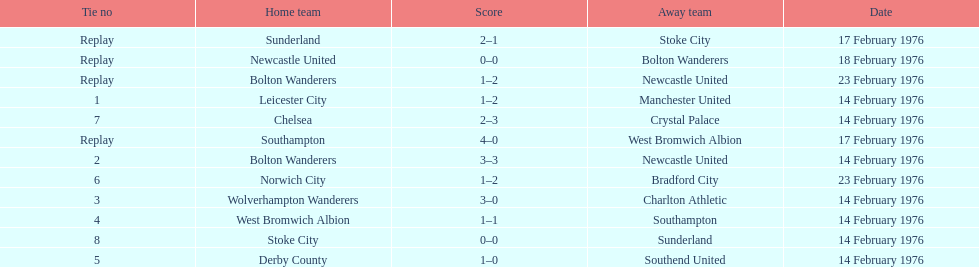What teams are featured in the game at the top of the table? Leicester City, Manchester United. Which of these two is the home team? Leicester City. 